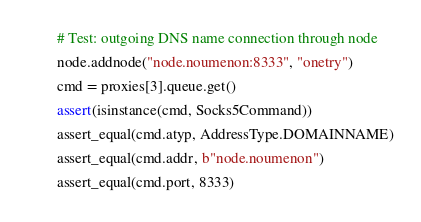Convert code to text. <code><loc_0><loc_0><loc_500><loc_500><_Python_>        # Test: outgoing DNS name connection through node
        node.addnode("node.noumenon:8333", "onetry")
        cmd = proxies[3].queue.get()
        assert(isinstance(cmd, Socks5Command))
        assert_equal(cmd.atyp, AddressType.DOMAINNAME)
        assert_equal(cmd.addr, b"node.noumenon")
        assert_equal(cmd.port, 8333)</code> 